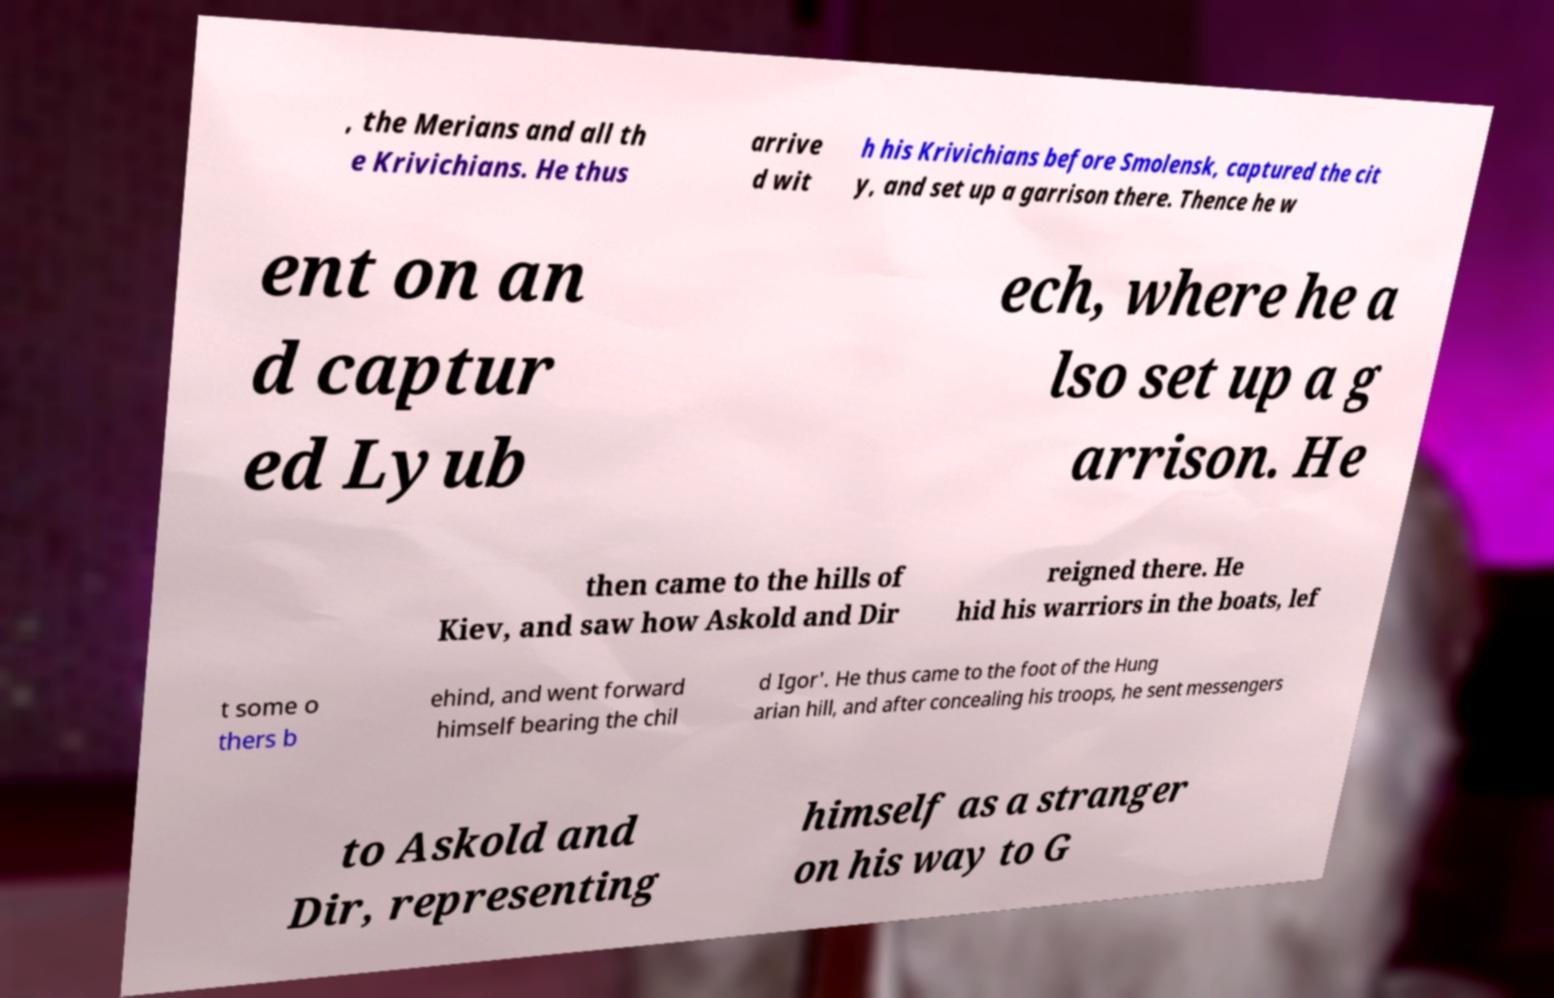Could you assist in decoding the text presented in this image and type it out clearly? , the Merians and all th e Krivichians. He thus arrive d wit h his Krivichians before Smolensk, captured the cit y, and set up a garrison there. Thence he w ent on an d captur ed Lyub ech, where he a lso set up a g arrison. He then came to the hills of Kiev, and saw how Askold and Dir reigned there. He hid his warriors in the boats, lef t some o thers b ehind, and went forward himself bearing the chil d Igor'. He thus came to the foot of the Hung arian hill, and after concealing his troops, he sent messengers to Askold and Dir, representing himself as a stranger on his way to G 